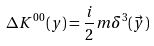Convert formula to latex. <formula><loc_0><loc_0><loc_500><loc_500>\Delta K ^ { 0 0 } ( y ) = \frac { i } { 2 } m \delta ^ { 3 } ( \vec { y } )</formula> 